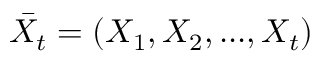<formula> <loc_0><loc_0><loc_500><loc_500>\bar { X _ { t } } = ( X _ { 1 } , X _ { 2 } , \dots , X _ { t } )</formula> 